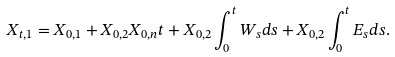Convert formula to latex. <formula><loc_0><loc_0><loc_500><loc_500>X _ { t , 1 } = X _ { 0 , 1 } + X _ { 0 , 2 } X _ { 0 , n } t + X _ { 0 , 2 } \int _ { 0 } ^ { t } W _ { s } d s + X _ { 0 , 2 } \int _ { 0 } ^ { t } E _ { s } d s .</formula> 